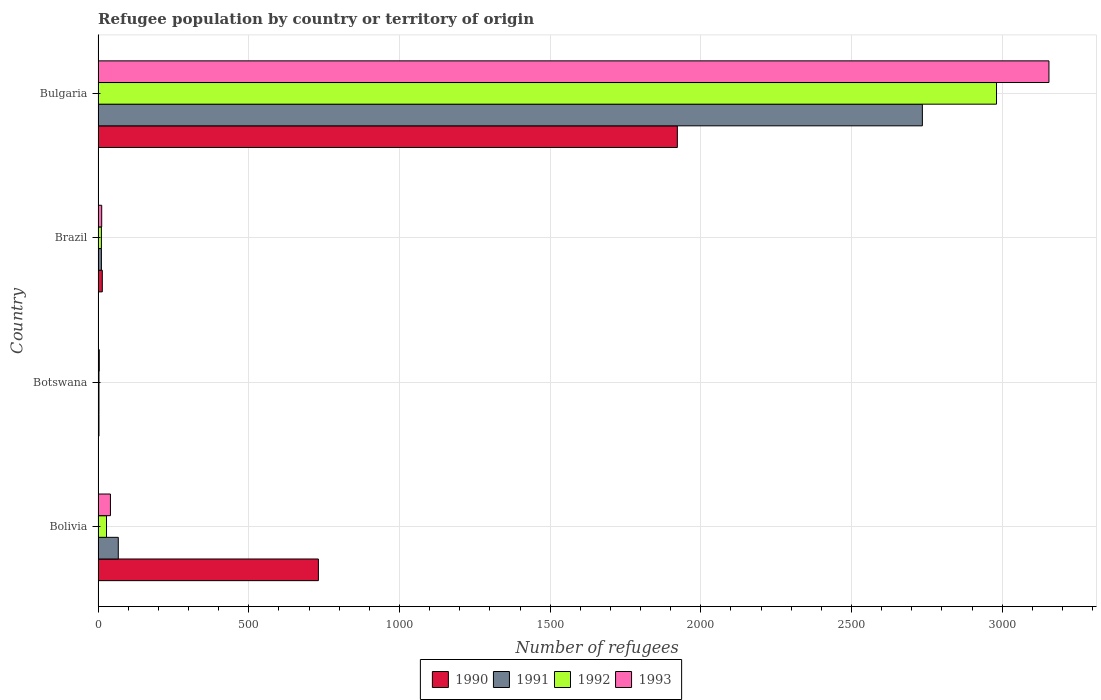How many different coloured bars are there?
Make the answer very short. 4. How many groups of bars are there?
Ensure brevity in your answer.  4. Are the number of bars per tick equal to the number of legend labels?
Offer a terse response. Yes. How many bars are there on the 1st tick from the top?
Make the answer very short. 4. What is the label of the 4th group of bars from the top?
Offer a terse response. Bolivia. Across all countries, what is the maximum number of refugees in 1993?
Your response must be concise. 3155. In which country was the number of refugees in 1990 minimum?
Offer a very short reply. Botswana. What is the total number of refugees in 1992 in the graph?
Ensure brevity in your answer.  3023. What is the difference between the number of refugees in 1992 in Bolivia and that in Bulgaria?
Your answer should be compact. -2953. What is the difference between the number of refugees in 1990 in Botswana and the number of refugees in 1993 in Brazil?
Your answer should be compact. -9. What is the average number of refugees in 1991 per country?
Keep it short and to the point. 704. What is the difference between the number of refugees in 1990 and number of refugees in 1991 in Brazil?
Give a very brief answer. 3. In how many countries, is the number of refugees in 1993 greater than 2300 ?
Your response must be concise. 1. What is the ratio of the number of refugees in 1990 in Bolivia to that in Bulgaria?
Provide a succinct answer. 0.38. Is the difference between the number of refugees in 1990 in Bolivia and Botswana greater than the difference between the number of refugees in 1991 in Bolivia and Botswana?
Give a very brief answer. Yes. What is the difference between the highest and the second highest number of refugees in 1993?
Your answer should be very brief. 3114. What is the difference between the highest and the lowest number of refugees in 1992?
Offer a terse response. 2978. In how many countries, is the number of refugees in 1993 greater than the average number of refugees in 1993 taken over all countries?
Provide a short and direct response. 1. Is the sum of the number of refugees in 1991 in Bolivia and Bulgaria greater than the maximum number of refugees in 1993 across all countries?
Provide a short and direct response. No. Is it the case that in every country, the sum of the number of refugees in 1990 and number of refugees in 1991 is greater than the sum of number of refugees in 1993 and number of refugees in 1992?
Keep it short and to the point. No. How many bars are there?
Provide a succinct answer. 16. Does the graph contain any zero values?
Offer a terse response. No. Where does the legend appear in the graph?
Your response must be concise. Bottom center. How many legend labels are there?
Your answer should be compact. 4. How are the legend labels stacked?
Offer a very short reply. Horizontal. What is the title of the graph?
Your response must be concise. Refugee population by country or territory of origin. Does "1986" appear as one of the legend labels in the graph?
Provide a succinct answer. No. What is the label or title of the X-axis?
Keep it short and to the point. Number of refugees. What is the Number of refugees in 1990 in Bolivia?
Provide a short and direct response. 731. What is the Number of refugees of 1990 in Botswana?
Ensure brevity in your answer.  3. What is the Number of refugees in 1990 in Brazil?
Keep it short and to the point. 14. What is the Number of refugees of 1991 in Brazil?
Provide a short and direct response. 11. What is the Number of refugees in 1992 in Brazil?
Make the answer very short. 11. What is the Number of refugees of 1990 in Bulgaria?
Provide a short and direct response. 1922. What is the Number of refugees of 1991 in Bulgaria?
Offer a very short reply. 2735. What is the Number of refugees of 1992 in Bulgaria?
Offer a terse response. 2981. What is the Number of refugees of 1993 in Bulgaria?
Keep it short and to the point. 3155. Across all countries, what is the maximum Number of refugees in 1990?
Offer a very short reply. 1922. Across all countries, what is the maximum Number of refugees of 1991?
Give a very brief answer. 2735. Across all countries, what is the maximum Number of refugees of 1992?
Your answer should be very brief. 2981. Across all countries, what is the maximum Number of refugees of 1993?
Ensure brevity in your answer.  3155. Across all countries, what is the minimum Number of refugees of 1990?
Provide a succinct answer. 3. Across all countries, what is the minimum Number of refugees of 1992?
Make the answer very short. 3. What is the total Number of refugees in 1990 in the graph?
Provide a short and direct response. 2670. What is the total Number of refugees in 1991 in the graph?
Ensure brevity in your answer.  2816. What is the total Number of refugees in 1992 in the graph?
Provide a short and direct response. 3023. What is the total Number of refugees of 1993 in the graph?
Offer a very short reply. 3212. What is the difference between the Number of refugees of 1990 in Bolivia and that in Botswana?
Keep it short and to the point. 728. What is the difference between the Number of refugees of 1993 in Bolivia and that in Botswana?
Provide a short and direct response. 37. What is the difference between the Number of refugees in 1990 in Bolivia and that in Brazil?
Provide a short and direct response. 717. What is the difference between the Number of refugees in 1991 in Bolivia and that in Brazil?
Offer a terse response. 56. What is the difference between the Number of refugees in 1993 in Bolivia and that in Brazil?
Provide a short and direct response. 29. What is the difference between the Number of refugees of 1990 in Bolivia and that in Bulgaria?
Ensure brevity in your answer.  -1191. What is the difference between the Number of refugees of 1991 in Bolivia and that in Bulgaria?
Offer a very short reply. -2668. What is the difference between the Number of refugees in 1992 in Bolivia and that in Bulgaria?
Your answer should be very brief. -2953. What is the difference between the Number of refugees of 1993 in Bolivia and that in Bulgaria?
Your answer should be compact. -3114. What is the difference between the Number of refugees of 1990 in Botswana and that in Brazil?
Your response must be concise. -11. What is the difference between the Number of refugees of 1992 in Botswana and that in Brazil?
Your answer should be very brief. -8. What is the difference between the Number of refugees in 1993 in Botswana and that in Brazil?
Your answer should be compact. -8. What is the difference between the Number of refugees in 1990 in Botswana and that in Bulgaria?
Offer a terse response. -1919. What is the difference between the Number of refugees of 1991 in Botswana and that in Bulgaria?
Your response must be concise. -2732. What is the difference between the Number of refugees of 1992 in Botswana and that in Bulgaria?
Provide a succinct answer. -2978. What is the difference between the Number of refugees in 1993 in Botswana and that in Bulgaria?
Your answer should be very brief. -3151. What is the difference between the Number of refugees in 1990 in Brazil and that in Bulgaria?
Keep it short and to the point. -1908. What is the difference between the Number of refugees in 1991 in Brazil and that in Bulgaria?
Offer a very short reply. -2724. What is the difference between the Number of refugees in 1992 in Brazil and that in Bulgaria?
Make the answer very short. -2970. What is the difference between the Number of refugees of 1993 in Brazil and that in Bulgaria?
Ensure brevity in your answer.  -3143. What is the difference between the Number of refugees in 1990 in Bolivia and the Number of refugees in 1991 in Botswana?
Ensure brevity in your answer.  728. What is the difference between the Number of refugees of 1990 in Bolivia and the Number of refugees of 1992 in Botswana?
Your response must be concise. 728. What is the difference between the Number of refugees in 1990 in Bolivia and the Number of refugees in 1993 in Botswana?
Offer a terse response. 727. What is the difference between the Number of refugees in 1991 in Bolivia and the Number of refugees in 1992 in Botswana?
Keep it short and to the point. 64. What is the difference between the Number of refugees in 1992 in Bolivia and the Number of refugees in 1993 in Botswana?
Make the answer very short. 24. What is the difference between the Number of refugees of 1990 in Bolivia and the Number of refugees of 1991 in Brazil?
Ensure brevity in your answer.  720. What is the difference between the Number of refugees of 1990 in Bolivia and the Number of refugees of 1992 in Brazil?
Your response must be concise. 720. What is the difference between the Number of refugees in 1990 in Bolivia and the Number of refugees in 1993 in Brazil?
Offer a terse response. 719. What is the difference between the Number of refugees in 1991 in Bolivia and the Number of refugees in 1993 in Brazil?
Your response must be concise. 55. What is the difference between the Number of refugees in 1992 in Bolivia and the Number of refugees in 1993 in Brazil?
Give a very brief answer. 16. What is the difference between the Number of refugees in 1990 in Bolivia and the Number of refugees in 1991 in Bulgaria?
Provide a short and direct response. -2004. What is the difference between the Number of refugees in 1990 in Bolivia and the Number of refugees in 1992 in Bulgaria?
Keep it short and to the point. -2250. What is the difference between the Number of refugees of 1990 in Bolivia and the Number of refugees of 1993 in Bulgaria?
Give a very brief answer. -2424. What is the difference between the Number of refugees in 1991 in Bolivia and the Number of refugees in 1992 in Bulgaria?
Give a very brief answer. -2914. What is the difference between the Number of refugees of 1991 in Bolivia and the Number of refugees of 1993 in Bulgaria?
Keep it short and to the point. -3088. What is the difference between the Number of refugees of 1992 in Bolivia and the Number of refugees of 1993 in Bulgaria?
Make the answer very short. -3127. What is the difference between the Number of refugees in 1990 in Botswana and the Number of refugees in 1991 in Brazil?
Ensure brevity in your answer.  -8. What is the difference between the Number of refugees in 1990 in Botswana and the Number of refugees in 1992 in Brazil?
Ensure brevity in your answer.  -8. What is the difference between the Number of refugees in 1991 in Botswana and the Number of refugees in 1992 in Brazil?
Ensure brevity in your answer.  -8. What is the difference between the Number of refugees of 1990 in Botswana and the Number of refugees of 1991 in Bulgaria?
Make the answer very short. -2732. What is the difference between the Number of refugees in 1990 in Botswana and the Number of refugees in 1992 in Bulgaria?
Your answer should be very brief. -2978. What is the difference between the Number of refugees in 1990 in Botswana and the Number of refugees in 1993 in Bulgaria?
Your answer should be compact. -3152. What is the difference between the Number of refugees in 1991 in Botswana and the Number of refugees in 1992 in Bulgaria?
Offer a terse response. -2978. What is the difference between the Number of refugees in 1991 in Botswana and the Number of refugees in 1993 in Bulgaria?
Your answer should be compact. -3152. What is the difference between the Number of refugees in 1992 in Botswana and the Number of refugees in 1993 in Bulgaria?
Provide a short and direct response. -3152. What is the difference between the Number of refugees in 1990 in Brazil and the Number of refugees in 1991 in Bulgaria?
Your response must be concise. -2721. What is the difference between the Number of refugees of 1990 in Brazil and the Number of refugees of 1992 in Bulgaria?
Offer a terse response. -2967. What is the difference between the Number of refugees of 1990 in Brazil and the Number of refugees of 1993 in Bulgaria?
Provide a succinct answer. -3141. What is the difference between the Number of refugees of 1991 in Brazil and the Number of refugees of 1992 in Bulgaria?
Provide a short and direct response. -2970. What is the difference between the Number of refugees in 1991 in Brazil and the Number of refugees in 1993 in Bulgaria?
Provide a succinct answer. -3144. What is the difference between the Number of refugees of 1992 in Brazil and the Number of refugees of 1993 in Bulgaria?
Your answer should be compact. -3144. What is the average Number of refugees in 1990 per country?
Your answer should be compact. 667.5. What is the average Number of refugees of 1991 per country?
Ensure brevity in your answer.  704. What is the average Number of refugees of 1992 per country?
Make the answer very short. 755.75. What is the average Number of refugees in 1993 per country?
Offer a very short reply. 803. What is the difference between the Number of refugees of 1990 and Number of refugees of 1991 in Bolivia?
Ensure brevity in your answer.  664. What is the difference between the Number of refugees in 1990 and Number of refugees in 1992 in Bolivia?
Make the answer very short. 703. What is the difference between the Number of refugees of 1990 and Number of refugees of 1993 in Bolivia?
Your answer should be compact. 690. What is the difference between the Number of refugees of 1991 and Number of refugees of 1992 in Bolivia?
Your answer should be compact. 39. What is the difference between the Number of refugees of 1991 and Number of refugees of 1993 in Bolivia?
Your response must be concise. 26. What is the difference between the Number of refugees in 1992 and Number of refugees in 1993 in Bolivia?
Your answer should be compact. -13. What is the difference between the Number of refugees of 1990 and Number of refugees of 1991 in Botswana?
Your response must be concise. 0. What is the difference between the Number of refugees of 1990 and Number of refugees of 1992 in Botswana?
Make the answer very short. 0. What is the difference between the Number of refugees of 1991 and Number of refugees of 1993 in Botswana?
Make the answer very short. -1. What is the difference between the Number of refugees of 1990 and Number of refugees of 1991 in Brazil?
Provide a succinct answer. 3. What is the difference between the Number of refugees of 1990 and Number of refugees of 1993 in Brazil?
Offer a very short reply. 2. What is the difference between the Number of refugees of 1990 and Number of refugees of 1991 in Bulgaria?
Your answer should be compact. -813. What is the difference between the Number of refugees of 1990 and Number of refugees of 1992 in Bulgaria?
Ensure brevity in your answer.  -1059. What is the difference between the Number of refugees in 1990 and Number of refugees in 1993 in Bulgaria?
Ensure brevity in your answer.  -1233. What is the difference between the Number of refugees of 1991 and Number of refugees of 1992 in Bulgaria?
Your answer should be compact. -246. What is the difference between the Number of refugees of 1991 and Number of refugees of 1993 in Bulgaria?
Provide a short and direct response. -420. What is the difference between the Number of refugees in 1992 and Number of refugees in 1993 in Bulgaria?
Your answer should be very brief. -174. What is the ratio of the Number of refugees in 1990 in Bolivia to that in Botswana?
Offer a very short reply. 243.67. What is the ratio of the Number of refugees in 1991 in Bolivia to that in Botswana?
Give a very brief answer. 22.33. What is the ratio of the Number of refugees of 1992 in Bolivia to that in Botswana?
Your response must be concise. 9.33. What is the ratio of the Number of refugees of 1993 in Bolivia to that in Botswana?
Keep it short and to the point. 10.25. What is the ratio of the Number of refugees in 1990 in Bolivia to that in Brazil?
Make the answer very short. 52.21. What is the ratio of the Number of refugees in 1991 in Bolivia to that in Brazil?
Provide a short and direct response. 6.09. What is the ratio of the Number of refugees in 1992 in Bolivia to that in Brazil?
Ensure brevity in your answer.  2.55. What is the ratio of the Number of refugees in 1993 in Bolivia to that in Brazil?
Your answer should be very brief. 3.42. What is the ratio of the Number of refugees in 1990 in Bolivia to that in Bulgaria?
Make the answer very short. 0.38. What is the ratio of the Number of refugees of 1991 in Bolivia to that in Bulgaria?
Your response must be concise. 0.02. What is the ratio of the Number of refugees of 1992 in Bolivia to that in Bulgaria?
Make the answer very short. 0.01. What is the ratio of the Number of refugees of 1993 in Bolivia to that in Bulgaria?
Offer a very short reply. 0.01. What is the ratio of the Number of refugees in 1990 in Botswana to that in Brazil?
Ensure brevity in your answer.  0.21. What is the ratio of the Number of refugees of 1991 in Botswana to that in Brazil?
Ensure brevity in your answer.  0.27. What is the ratio of the Number of refugees of 1992 in Botswana to that in Brazil?
Your answer should be compact. 0.27. What is the ratio of the Number of refugees of 1990 in Botswana to that in Bulgaria?
Provide a short and direct response. 0. What is the ratio of the Number of refugees in 1991 in Botswana to that in Bulgaria?
Make the answer very short. 0. What is the ratio of the Number of refugees of 1993 in Botswana to that in Bulgaria?
Keep it short and to the point. 0. What is the ratio of the Number of refugees of 1990 in Brazil to that in Bulgaria?
Give a very brief answer. 0.01. What is the ratio of the Number of refugees in 1991 in Brazil to that in Bulgaria?
Offer a very short reply. 0. What is the ratio of the Number of refugees in 1992 in Brazil to that in Bulgaria?
Offer a terse response. 0. What is the ratio of the Number of refugees in 1993 in Brazil to that in Bulgaria?
Offer a very short reply. 0. What is the difference between the highest and the second highest Number of refugees in 1990?
Offer a very short reply. 1191. What is the difference between the highest and the second highest Number of refugees in 1991?
Ensure brevity in your answer.  2668. What is the difference between the highest and the second highest Number of refugees in 1992?
Offer a very short reply. 2953. What is the difference between the highest and the second highest Number of refugees in 1993?
Keep it short and to the point. 3114. What is the difference between the highest and the lowest Number of refugees of 1990?
Your response must be concise. 1919. What is the difference between the highest and the lowest Number of refugees in 1991?
Your answer should be compact. 2732. What is the difference between the highest and the lowest Number of refugees of 1992?
Offer a terse response. 2978. What is the difference between the highest and the lowest Number of refugees of 1993?
Keep it short and to the point. 3151. 